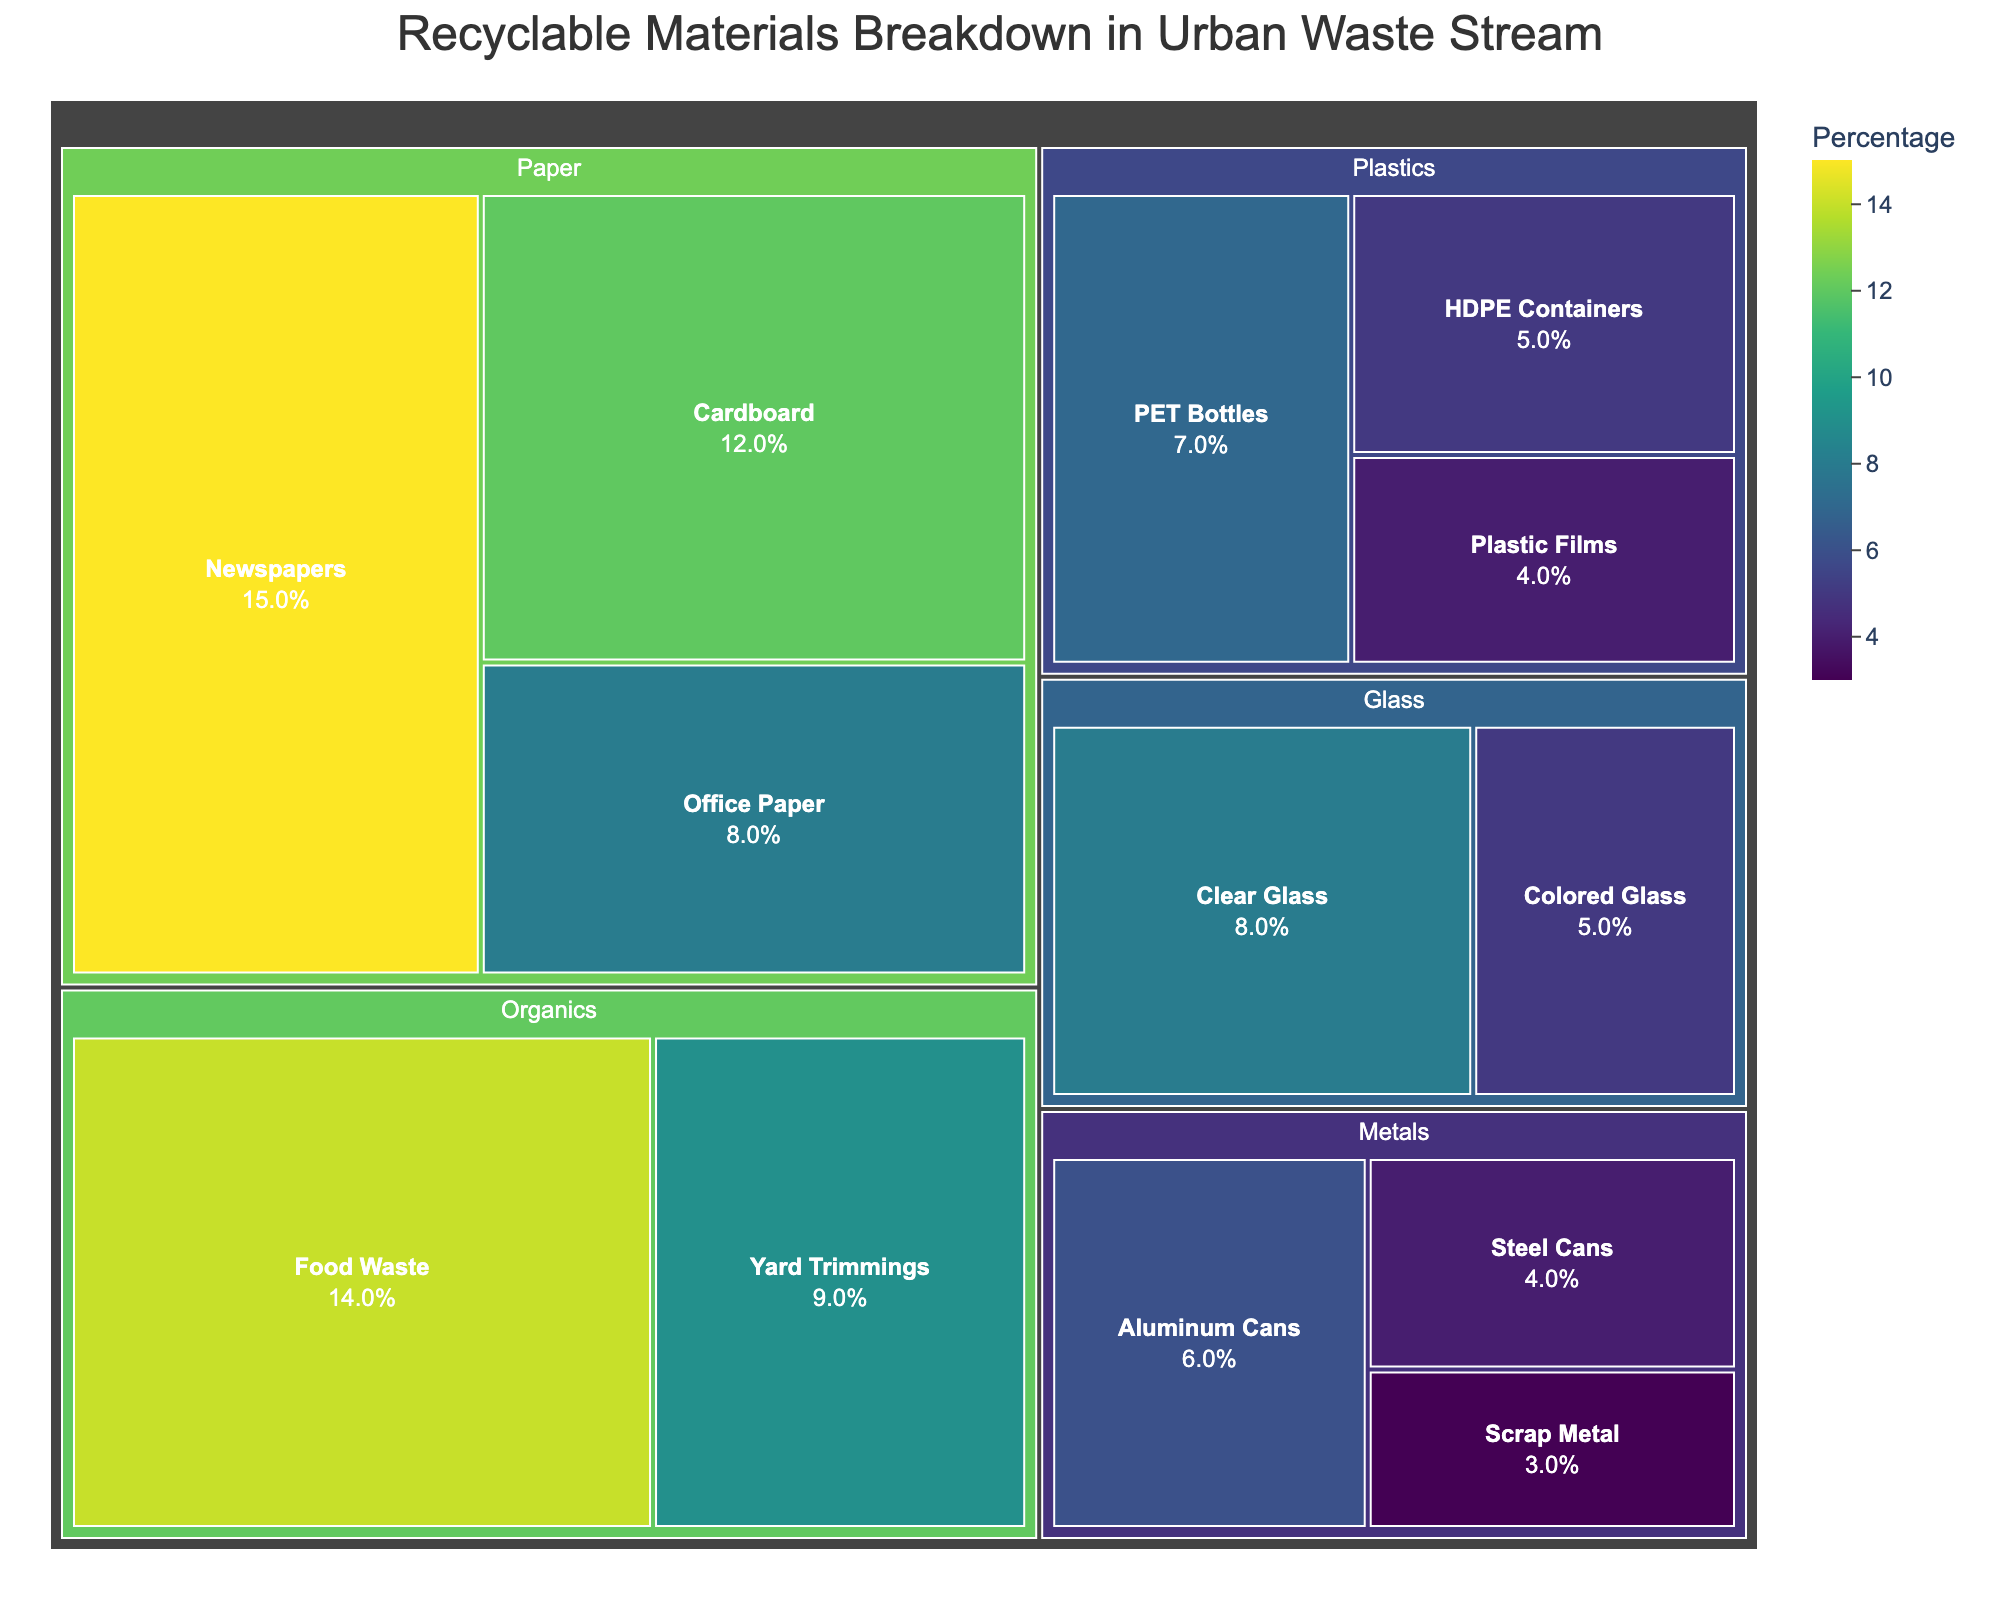What's the title of the figure? The title is usually placed prominently at the top of the figure. It provides a quick understanding of what the figure is about.
Answer: Recyclable Materials Breakdown in Urban Waste Stream Which category has the highest percentage in the figure? By examining the largest sections in the Treemap, we can identify which category has the highest percentage.
Answer: Paper What is the combined percentage of all subcategories under Plastics? Sum the percentages of all the subcategories listed under Plastics. (7 + 5 + 4) = 16.
Answer: 16% Which subcategory has the smallest percentage value? By looking at the smallest sections in the Treemap, we can identify which subcategory has the smallest percentage.
Answer: Scrap Metal Which two subcategories combined give the highest percentage? Identify the two largest sections in the Treemap and sum their percentages. Newspapers (15%) and Food Waste (14%) give the highest combined percentage: (15 + 14) = 29.
Answer: Newspapers and Food Waste What is the percentage difference between Clear Glass and Colored Glass? Subtract the percentage value of Colored Glass from that of Clear Glass. (8 - 5) = 3.
Answer: 3% Which category contains the subcategory with the second highest percentage? Identify the subcategory with the second highest percentage and note its category. Cardboard under Paper has 12%, which is the second highest after Newspapers (15%).
Answer: Paper Are there more subcategories under Paper or under Metals? Count the number of subcategories listed under each of Paper and Metals. Paper has 3 subcategories, while Metals also has 3.
Answer: They are equal Which recycling category represents more than 10% of the total waste stream? Identify any category where the total percentage of its subcategories sums to more than 10%. Paper sums to 35% (15+12+8), which is more than 10%.
Answer: Paper What is the sum percentage of all subcategories under Organics? Sum the percentages of Yard Trimmings (9%) and Food Waste (14%). (9 + 14) = 23.
Answer: 23% 